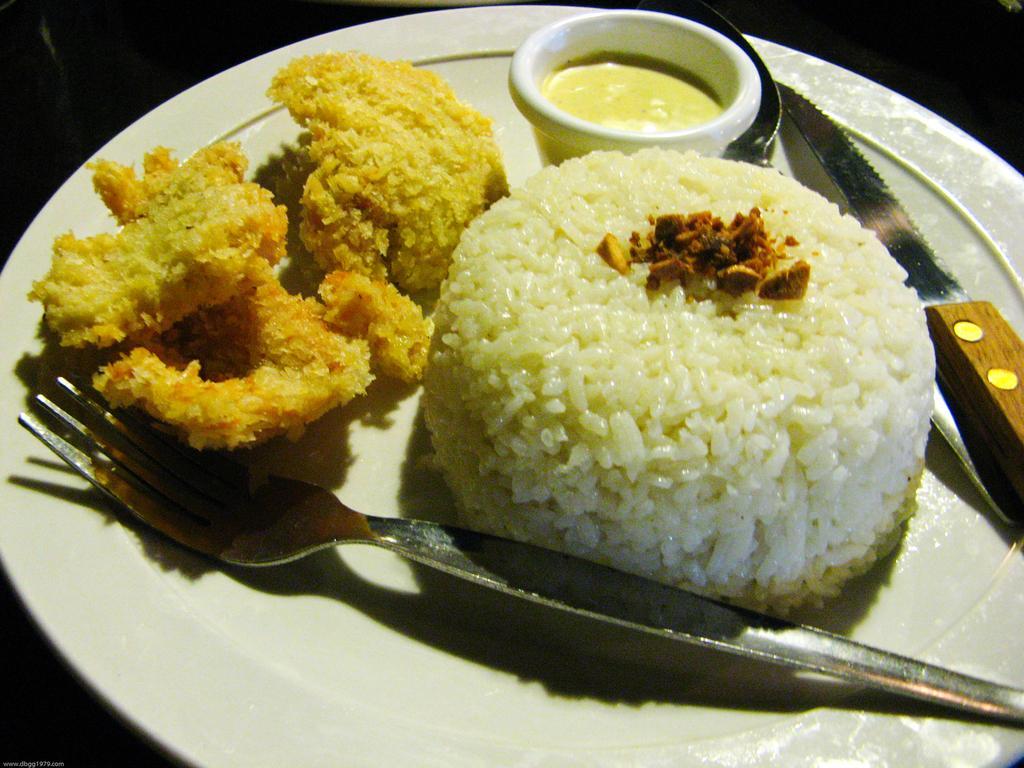Describe this image in one or two sentences. In this picture we can see some food, knife, a liquid in a bowl, fork on a plate. Background is black in color. 